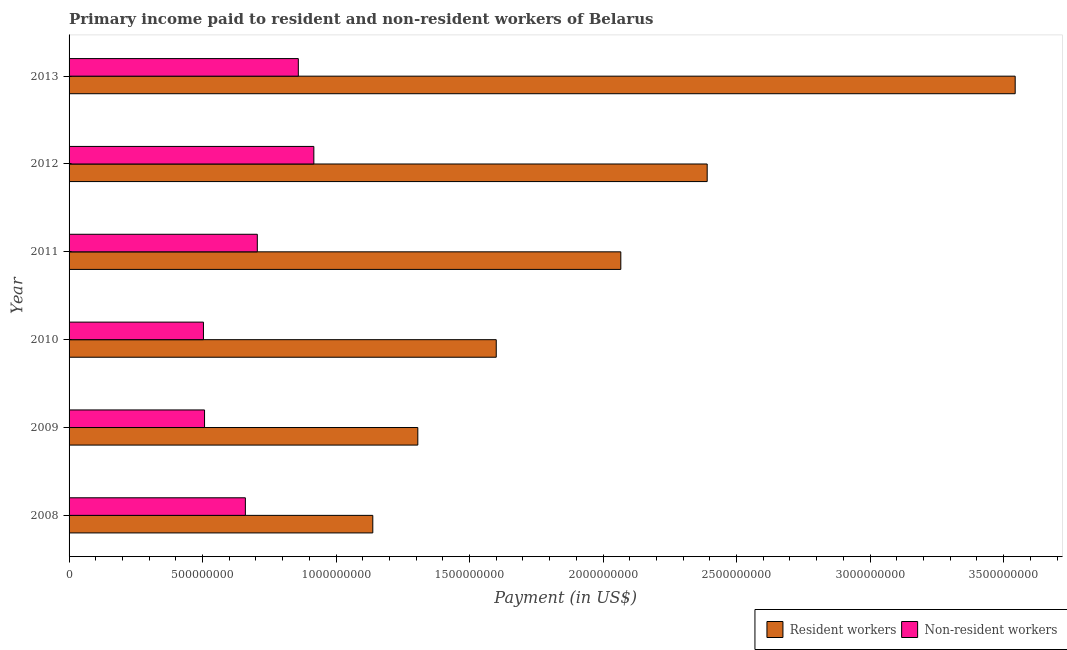How many different coloured bars are there?
Make the answer very short. 2. Are the number of bars per tick equal to the number of legend labels?
Give a very brief answer. Yes. What is the payment made to non-resident workers in 2010?
Provide a succinct answer. 5.03e+08. Across all years, what is the maximum payment made to resident workers?
Ensure brevity in your answer.  3.54e+09. Across all years, what is the minimum payment made to resident workers?
Keep it short and to the point. 1.14e+09. In which year was the payment made to non-resident workers minimum?
Offer a terse response. 2010. What is the total payment made to resident workers in the graph?
Provide a short and direct response. 1.20e+1. What is the difference between the payment made to resident workers in 2012 and that in 2013?
Provide a succinct answer. -1.15e+09. What is the difference between the payment made to resident workers in 2008 and the payment made to non-resident workers in 2013?
Your response must be concise. 2.79e+08. What is the average payment made to resident workers per year?
Provide a short and direct response. 2.01e+09. In the year 2010, what is the difference between the payment made to resident workers and payment made to non-resident workers?
Provide a short and direct response. 1.10e+09. What is the ratio of the payment made to resident workers in 2008 to that in 2009?
Your response must be concise. 0.87. What is the difference between the highest and the second highest payment made to resident workers?
Provide a short and direct response. 1.15e+09. What is the difference between the highest and the lowest payment made to non-resident workers?
Offer a very short reply. 4.13e+08. In how many years, is the payment made to resident workers greater than the average payment made to resident workers taken over all years?
Give a very brief answer. 3. What does the 1st bar from the top in 2013 represents?
Offer a very short reply. Non-resident workers. What does the 1st bar from the bottom in 2010 represents?
Offer a very short reply. Resident workers. How many bars are there?
Your response must be concise. 12. How many years are there in the graph?
Provide a succinct answer. 6. Does the graph contain grids?
Keep it short and to the point. No. Where does the legend appear in the graph?
Your response must be concise. Bottom right. What is the title of the graph?
Ensure brevity in your answer.  Primary income paid to resident and non-resident workers of Belarus. Does "Lowest 10% of population" appear as one of the legend labels in the graph?
Give a very brief answer. No. What is the label or title of the X-axis?
Ensure brevity in your answer.  Payment (in US$). What is the label or title of the Y-axis?
Offer a terse response. Year. What is the Payment (in US$) of Resident workers in 2008?
Ensure brevity in your answer.  1.14e+09. What is the Payment (in US$) of Non-resident workers in 2008?
Offer a terse response. 6.60e+08. What is the Payment (in US$) in Resident workers in 2009?
Ensure brevity in your answer.  1.31e+09. What is the Payment (in US$) in Non-resident workers in 2009?
Offer a very short reply. 5.07e+08. What is the Payment (in US$) of Resident workers in 2010?
Offer a terse response. 1.60e+09. What is the Payment (in US$) in Non-resident workers in 2010?
Provide a short and direct response. 5.03e+08. What is the Payment (in US$) in Resident workers in 2011?
Your response must be concise. 2.07e+09. What is the Payment (in US$) of Non-resident workers in 2011?
Offer a terse response. 7.05e+08. What is the Payment (in US$) in Resident workers in 2012?
Offer a terse response. 2.39e+09. What is the Payment (in US$) in Non-resident workers in 2012?
Give a very brief answer. 9.17e+08. What is the Payment (in US$) in Resident workers in 2013?
Offer a very short reply. 3.54e+09. What is the Payment (in US$) in Non-resident workers in 2013?
Your answer should be compact. 8.59e+08. Across all years, what is the maximum Payment (in US$) of Resident workers?
Your answer should be very brief. 3.54e+09. Across all years, what is the maximum Payment (in US$) in Non-resident workers?
Make the answer very short. 9.17e+08. Across all years, what is the minimum Payment (in US$) in Resident workers?
Your answer should be compact. 1.14e+09. Across all years, what is the minimum Payment (in US$) of Non-resident workers?
Make the answer very short. 5.03e+08. What is the total Payment (in US$) in Resident workers in the graph?
Ensure brevity in your answer.  1.20e+1. What is the total Payment (in US$) in Non-resident workers in the graph?
Offer a very short reply. 4.15e+09. What is the difference between the Payment (in US$) of Resident workers in 2008 and that in 2009?
Offer a very short reply. -1.69e+08. What is the difference between the Payment (in US$) of Non-resident workers in 2008 and that in 2009?
Provide a succinct answer. 1.53e+08. What is the difference between the Payment (in US$) of Resident workers in 2008 and that in 2010?
Your answer should be very brief. -4.62e+08. What is the difference between the Payment (in US$) of Non-resident workers in 2008 and that in 2010?
Keep it short and to the point. 1.57e+08. What is the difference between the Payment (in US$) of Resident workers in 2008 and that in 2011?
Provide a succinct answer. -9.29e+08. What is the difference between the Payment (in US$) of Non-resident workers in 2008 and that in 2011?
Your answer should be very brief. -4.47e+07. What is the difference between the Payment (in US$) in Resident workers in 2008 and that in 2012?
Ensure brevity in your answer.  -1.25e+09. What is the difference between the Payment (in US$) of Non-resident workers in 2008 and that in 2012?
Provide a short and direct response. -2.56e+08. What is the difference between the Payment (in US$) in Resident workers in 2008 and that in 2013?
Your answer should be compact. -2.41e+09. What is the difference between the Payment (in US$) in Non-resident workers in 2008 and that in 2013?
Provide a short and direct response. -1.98e+08. What is the difference between the Payment (in US$) in Resident workers in 2009 and that in 2010?
Your response must be concise. -2.94e+08. What is the difference between the Payment (in US$) of Non-resident workers in 2009 and that in 2010?
Give a very brief answer. 4.10e+06. What is the difference between the Payment (in US$) in Resident workers in 2009 and that in 2011?
Make the answer very short. -7.60e+08. What is the difference between the Payment (in US$) of Non-resident workers in 2009 and that in 2011?
Provide a short and direct response. -1.98e+08. What is the difference between the Payment (in US$) in Resident workers in 2009 and that in 2012?
Make the answer very short. -1.08e+09. What is the difference between the Payment (in US$) in Non-resident workers in 2009 and that in 2012?
Make the answer very short. -4.09e+08. What is the difference between the Payment (in US$) in Resident workers in 2009 and that in 2013?
Offer a terse response. -2.24e+09. What is the difference between the Payment (in US$) of Non-resident workers in 2009 and that in 2013?
Your response must be concise. -3.51e+08. What is the difference between the Payment (in US$) of Resident workers in 2010 and that in 2011?
Ensure brevity in your answer.  -4.66e+08. What is the difference between the Payment (in US$) in Non-resident workers in 2010 and that in 2011?
Offer a terse response. -2.02e+08. What is the difference between the Payment (in US$) of Resident workers in 2010 and that in 2012?
Provide a succinct answer. -7.90e+08. What is the difference between the Payment (in US$) of Non-resident workers in 2010 and that in 2012?
Provide a short and direct response. -4.13e+08. What is the difference between the Payment (in US$) in Resident workers in 2010 and that in 2013?
Provide a succinct answer. -1.94e+09. What is the difference between the Payment (in US$) of Non-resident workers in 2010 and that in 2013?
Provide a succinct answer. -3.55e+08. What is the difference between the Payment (in US$) of Resident workers in 2011 and that in 2012?
Your response must be concise. -3.24e+08. What is the difference between the Payment (in US$) in Non-resident workers in 2011 and that in 2012?
Your response must be concise. -2.12e+08. What is the difference between the Payment (in US$) in Resident workers in 2011 and that in 2013?
Keep it short and to the point. -1.48e+09. What is the difference between the Payment (in US$) of Non-resident workers in 2011 and that in 2013?
Make the answer very short. -1.54e+08. What is the difference between the Payment (in US$) in Resident workers in 2012 and that in 2013?
Offer a terse response. -1.15e+09. What is the difference between the Payment (in US$) of Non-resident workers in 2012 and that in 2013?
Provide a succinct answer. 5.81e+07. What is the difference between the Payment (in US$) of Resident workers in 2008 and the Payment (in US$) of Non-resident workers in 2009?
Make the answer very short. 6.30e+08. What is the difference between the Payment (in US$) of Resident workers in 2008 and the Payment (in US$) of Non-resident workers in 2010?
Provide a succinct answer. 6.34e+08. What is the difference between the Payment (in US$) in Resident workers in 2008 and the Payment (in US$) in Non-resident workers in 2011?
Provide a short and direct response. 4.32e+08. What is the difference between the Payment (in US$) in Resident workers in 2008 and the Payment (in US$) in Non-resident workers in 2012?
Keep it short and to the point. 2.21e+08. What is the difference between the Payment (in US$) in Resident workers in 2008 and the Payment (in US$) in Non-resident workers in 2013?
Your answer should be very brief. 2.79e+08. What is the difference between the Payment (in US$) in Resident workers in 2009 and the Payment (in US$) in Non-resident workers in 2010?
Make the answer very short. 8.03e+08. What is the difference between the Payment (in US$) in Resident workers in 2009 and the Payment (in US$) in Non-resident workers in 2011?
Offer a very short reply. 6.01e+08. What is the difference between the Payment (in US$) in Resident workers in 2009 and the Payment (in US$) in Non-resident workers in 2012?
Your answer should be very brief. 3.89e+08. What is the difference between the Payment (in US$) of Resident workers in 2009 and the Payment (in US$) of Non-resident workers in 2013?
Offer a very short reply. 4.48e+08. What is the difference between the Payment (in US$) in Resident workers in 2010 and the Payment (in US$) in Non-resident workers in 2011?
Ensure brevity in your answer.  8.95e+08. What is the difference between the Payment (in US$) in Resident workers in 2010 and the Payment (in US$) in Non-resident workers in 2012?
Your answer should be compact. 6.83e+08. What is the difference between the Payment (in US$) in Resident workers in 2010 and the Payment (in US$) in Non-resident workers in 2013?
Offer a terse response. 7.41e+08. What is the difference between the Payment (in US$) of Resident workers in 2011 and the Payment (in US$) of Non-resident workers in 2012?
Your response must be concise. 1.15e+09. What is the difference between the Payment (in US$) in Resident workers in 2011 and the Payment (in US$) in Non-resident workers in 2013?
Make the answer very short. 1.21e+09. What is the difference between the Payment (in US$) of Resident workers in 2012 and the Payment (in US$) of Non-resident workers in 2013?
Keep it short and to the point. 1.53e+09. What is the average Payment (in US$) in Resident workers per year?
Provide a succinct answer. 2.01e+09. What is the average Payment (in US$) of Non-resident workers per year?
Give a very brief answer. 6.92e+08. In the year 2008, what is the difference between the Payment (in US$) in Resident workers and Payment (in US$) in Non-resident workers?
Provide a short and direct response. 4.77e+08. In the year 2009, what is the difference between the Payment (in US$) of Resident workers and Payment (in US$) of Non-resident workers?
Offer a very short reply. 7.99e+08. In the year 2010, what is the difference between the Payment (in US$) of Resident workers and Payment (in US$) of Non-resident workers?
Ensure brevity in your answer.  1.10e+09. In the year 2011, what is the difference between the Payment (in US$) of Resident workers and Payment (in US$) of Non-resident workers?
Provide a succinct answer. 1.36e+09. In the year 2012, what is the difference between the Payment (in US$) in Resident workers and Payment (in US$) in Non-resident workers?
Provide a short and direct response. 1.47e+09. In the year 2013, what is the difference between the Payment (in US$) of Resident workers and Payment (in US$) of Non-resident workers?
Offer a terse response. 2.68e+09. What is the ratio of the Payment (in US$) of Resident workers in 2008 to that in 2009?
Provide a succinct answer. 0.87. What is the ratio of the Payment (in US$) of Non-resident workers in 2008 to that in 2009?
Give a very brief answer. 1.3. What is the ratio of the Payment (in US$) in Resident workers in 2008 to that in 2010?
Your answer should be very brief. 0.71. What is the ratio of the Payment (in US$) in Non-resident workers in 2008 to that in 2010?
Ensure brevity in your answer.  1.31. What is the ratio of the Payment (in US$) of Resident workers in 2008 to that in 2011?
Provide a succinct answer. 0.55. What is the ratio of the Payment (in US$) in Non-resident workers in 2008 to that in 2011?
Make the answer very short. 0.94. What is the ratio of the Payment (in US$) in Resident workers in 2008 to that in 2012?
Offer a terse response. 0.48. What is the ratio of the Payment (in US$) in Non-resident workers in 2008 to that in 2012?
Your response must be concise. 0.72. What is the ratio of the Payment (in US$) of Resident workers in 2008 to that in 2013?
Offer a very short reply. 0.32. What is the ratio of the Payment (in US$) of Non-resident workers in 2008 to that in 2013?
Provide a short and direct response. 0.77. What is the ratio of the Payment (in US$) of Resident workers in 2009 to that in 2010?
Ensure brevity in your answer.  0.82. What is the ratio of the Payment (in US$) of Resident workers in 2009 to that in 2011?
Make the answer very short. 0.63. What is the ratio of the Payment (in US$) in Non-resident workers in 2009 to that in 2011?
Provide a short and direct response. 0.72. What is the ratio of the Payment (in US$) in Resident workers in 2009 to that in 2012?
Make the answer very short. 0.55. What is the ratio of the Payment (in US$) of Non-resident workers in 2009 to that in 2012?
Your answer should be very brief. 0.55. What is the ratio of the Payment (in US$) in Resident workers in 2009 to that in 2013?
Ensure brevity in your answer.  0.37. What is the ratio of the Payment (in US$) in Non-resident workers in 2009 to that in 2013?
Your answer should be compact. 0.59. What is the ratio of the Payment (in US$) of Resident workers in 2010 to that in 2011?
Give a very brief answer. 0.77. What is the ratio of the Payment (in US$) of Non-resident workers in 2010 to that in 2011?
Provide a short and direct response. 0.71. What is the ratio of the Payment (in US$) in Resident workers in 2010 to that in 2012?
Your answer should be very brief. 0.67. What is the ratio of the Payment (in US$) in Non-resident workers in 2010 to that in 2012?
Make the answer very short. 0.55. What is the ratio of the Payment (in US$) in Resident workers in 2010 to that in 2013?
Provide a short and direct response. 0.45. What is the ratio of the Payment (in US$) of Non-resident workers in 2010 to that in 2013?
Your answer should be very brief. 0.59. What is the ratio of the Payment (in US$) in Resident workers in 2011 to that in 2012?
Keep it short and to the point. 0.86. What is the ratio of the Payment (in US$) of Non-resident workers in 2011 to that in 2012?
Your answer should be very brief. 0.77. What is the ratio of the Payment (in US$) in Resident workers in 2011 to that in 2013?
Offer a very short reply. 0.58. What is the ratio of the Payment (in US$) of Non-resident workers in 2011 to that in 2013?
Your answer should be compact. 0.82. What is the ratio of the Payment (in US$) of Resident workers in 2012 to that in 2013?
Provide a succinct answer. 0.67. What is the ratio of the Payment (in US$) of Non-resident workers in 2012 to that in 2013?
Provide a short and direct response. 1.07. What is the difference between the highest and the second highest Payment (in US$) in Resident workers?
Give a very brief answer. 1.15e+09. What is the difference between the highest and the second highest Payment (in US$) in Non-resident workers?
Offer a terse response. 5.81e+07. What is the difference between the highest and the lowest Payment (in US$) of Resident workers?
Make the answer very short. 2.41e+09. What is the difference between the highest and the lowest Payment (in US$) in Non-resident workers?
Offer a terse response. 4.13e+08. 